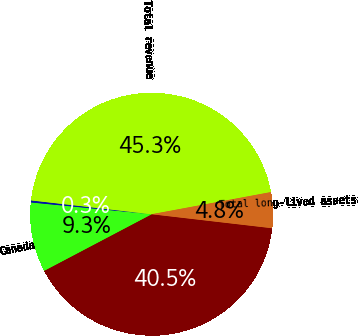Convert chart. <chart><loc_0><loc_0><loc_500><loc_500><pie_chart><fcel>United States<fcel>Canada<fcel>Other<fcel>Total revenue<fcel>Total long-lived assets<nl><fcel>40.45%<fcel>9.26%<fcel>0.27%<fcel>45.26%<fcel>4.76%<nl></chart> 